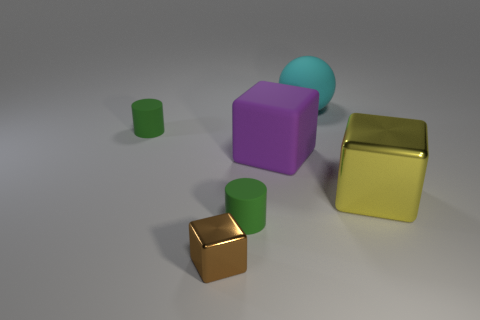What number of other objects are there of the same material as the yellow thing?
Your answer should be very brief. 1. There is a metal cube that is to the right of the large cyan rubber thing; how big is it?
Your response must be concise. Large. The brown thing that is the same material as the yellow block is what shape?
Keep it short and to the point. Cube. Does the tiny brown block have the same material as the big yellow cube that is in front of the big rubber ball?
Keep it short and to the point. Yes. Is the shape of the small green object right of the small brown block the same as  the large cyan object?
Provide a succinct answer. No. There is a small thing that is the same shape as the large purple thing; what material is it?
Ensure brevity in your answer.  Metal. Is the shape of the large purple rubber thing the same as the green object that is behind the large yellow thing?
Offer a terse response. No. What color is the object that is both on the right side of the brown metal object and behind the purple cube?
Give a very brief answer. Cyan. Are any big red cubes visible?
Offer a very short reply. No. Is the number of big spheres that are in front of the big metallic thing the same as the number of purple rubber things?
Keep it short and to the point. No. 